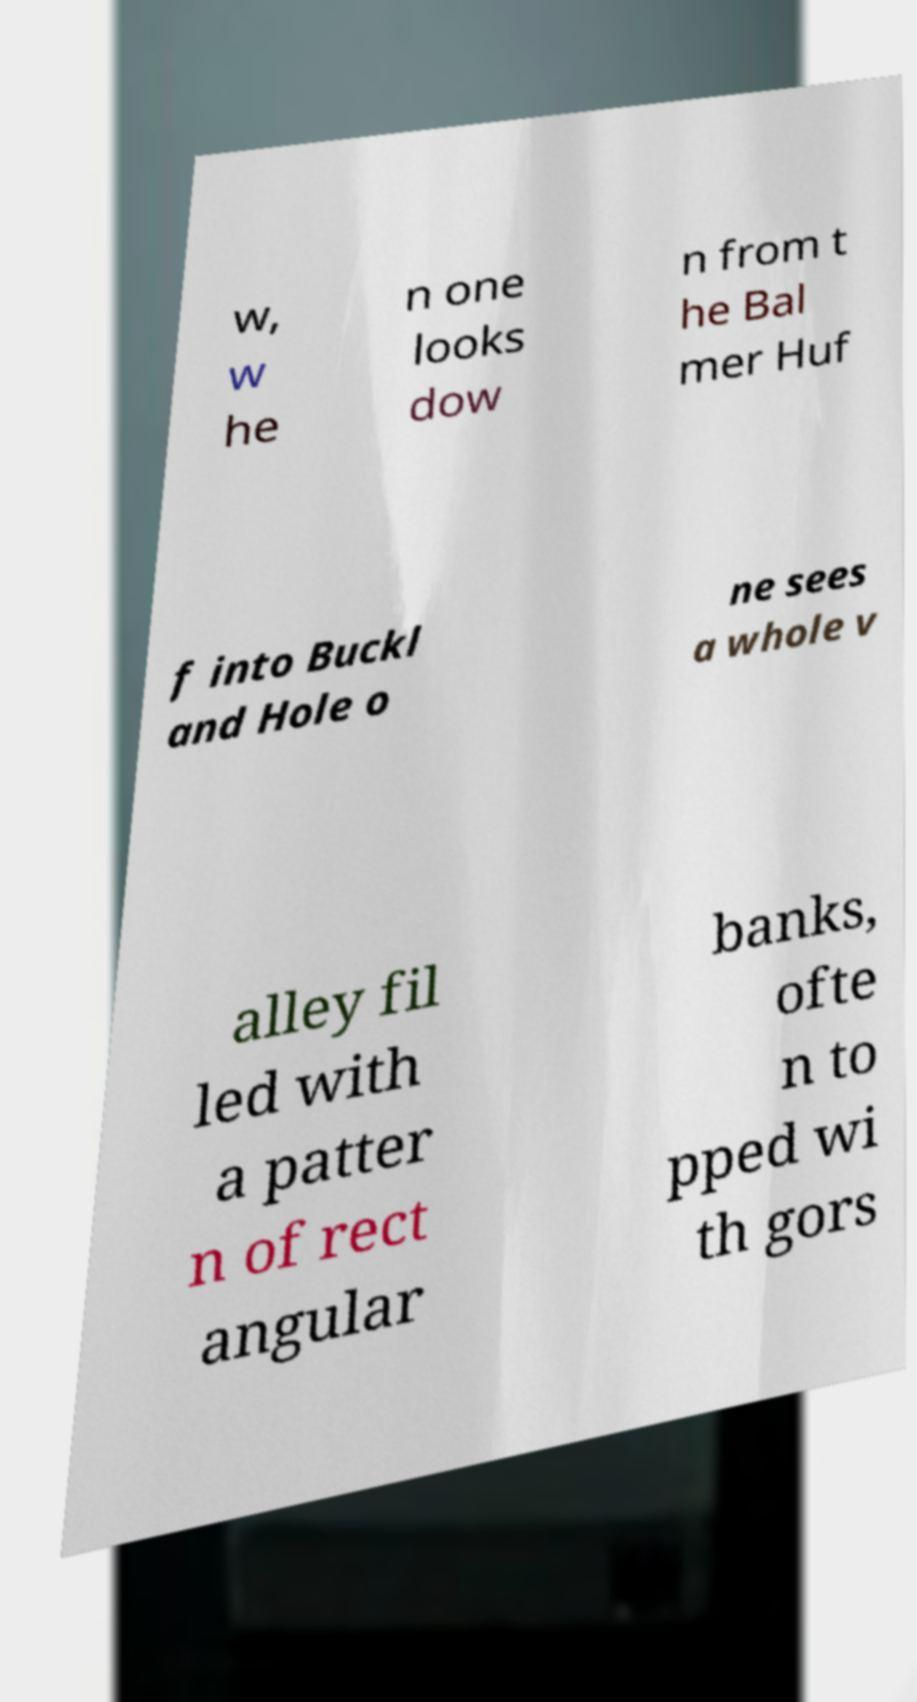There's text embedded in this image that I need extracted. Can you transcribe it verbatim? w, w he n one looks dow n from t he Bal mer Huf f into Buckl and Hole o ne sees a whole v alley fil led with a patter n of rect angular banks, ofte n to pped wi th gors 